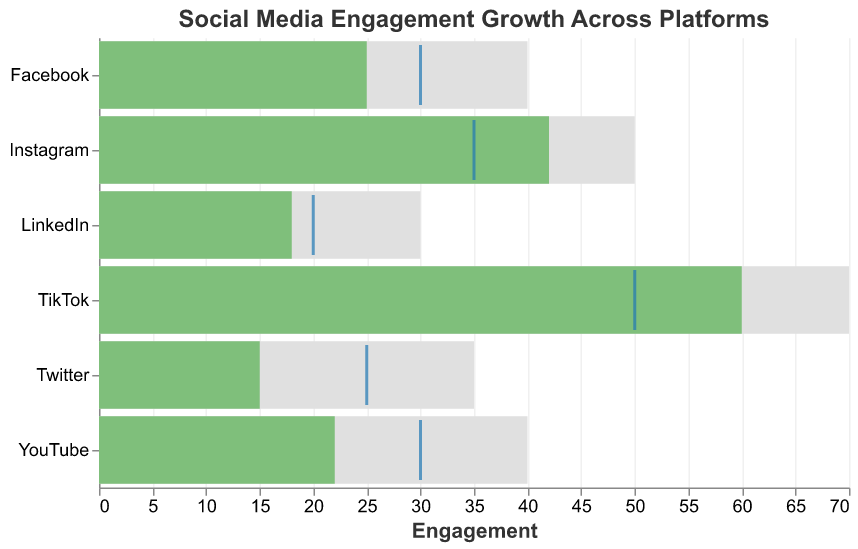What is the title of the chart? The title of the chart is usually found at the top of the chart, providing an overview of the chart's purpose or subject.
Answer: Social Media Engagement Growth Across Platforms Which platform has the highest actual engagement? Look at the "Actual" bar lengths for each platform. The longest bar represents the highest actual engagement.
Answer: TikTok How many platforms have their actual engagement below their target? Compare the positions of the "Actual" bars to the "Target" ticks for each platform to count the ones where the actual value is lower than the target value.
Answer: 4 What is the difference between the actual and target engagements for Instagram? Subtract the target engagement value from the actual engagement value for Instagram. Actual = 42, Target = 35. Difference = 42 - 35.
Answer: 7 Which platform has the smallest maximum engagement value? Look at the "Maximum" bar lengths for each platform. The shortest bar represents the smallest maximum engagement value.
Answer: LinkedIn Which two platforms have exactly the same target engagement value? Compare the "Target" tick positions for each platform to identify the ones that are aligned at the same value.
Answer: Facebook and YouTube For which platform is the actual engagement closest to the maximum engagement? Calculate the difference between the actual engagement and the maximum engagement for each platform, and find the one with the smallest difference. For TikTok, the difference is 70 - 60 = 10, which is the smallest compared to other platforms.
Answer: TikTok Is there any platform where the actual engagement exceeded the maximum value? Check the "Actual" bar lengths against the "Maximum" bar lengths. None of the actual values exceed the maximum values in this chart.
Answer: No Compare the actual engagement of LinkedIn and Twitter. Which platform has higher engagement? Look at and compare the "Actual" bar lengths for LinkedIn and Twitter.
Answer: LinkedIn 